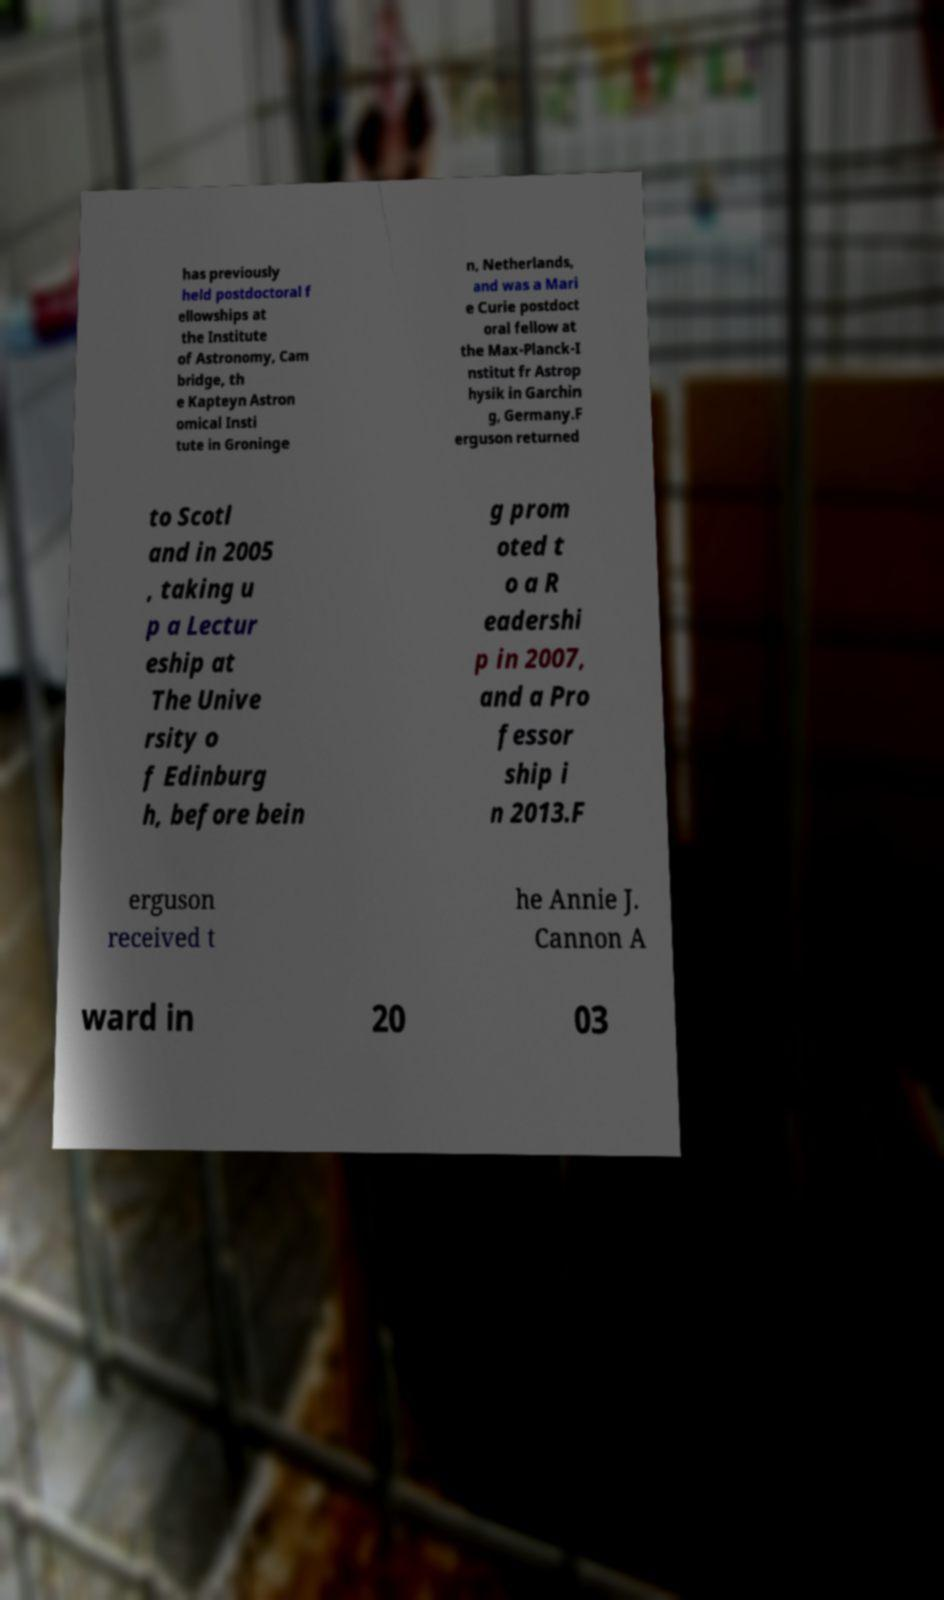What messages or text are displayed in this image? I need them in a readable, typed format. has previously held postdoctoral f ellowships at the Institute of Astronomy, Cam bridge, th e Kapteyn Astron omical Insti tute in Groninge n, Netherlands, and was a Mari e Curie postdoct oral fellow at the Max-Planck-I nstitut fr Astrop hysik in Garchin g, Germany.F erguson returned to Scotl and in 2005 , taking u p a Lectur eship at The Unive rsity o f Edinburg h, before bein g prom oted t o a R eadershi p in 2007, and a Pro fessor ship i n 2013.F erguson received t he Annie J. Cannon A ward in 20 03 